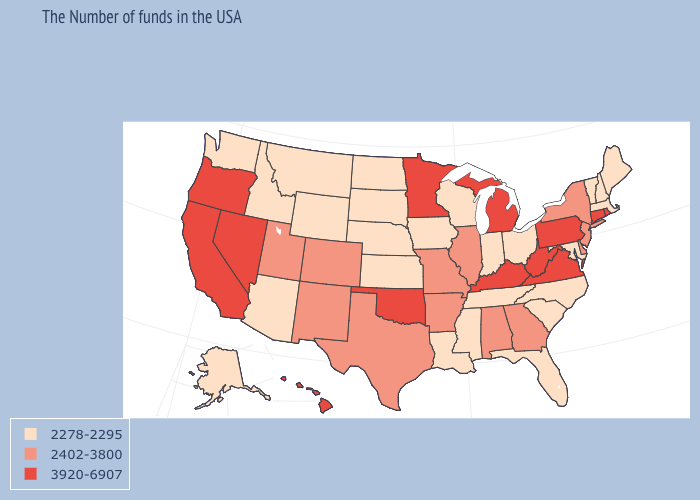Does the first symbol in the legend represent the smallest category?
Quick response, please. Yes. Does Wyoming have the lowest value in the USA?
Quick response, please. Yes. What is the lowest value in the USA?
Concise answer only. 2278-2295. Which states have the highest value in the USA?
Write a very short answer. Rhode Island, Connecticut, Pennsylvania, Virginia, West Virginia, Michigan, Kentucky, Minnesota, Oklahoma, Nevada, California, Oregon, Hawaii. Which states hav the highest value in the West?
Give a very brief answer. Nevada, California, Oregon, Hawaii. Which states hav the highest value in the MidWest?
Concise answer only. Michigan, Minnesota. Name the states that have a value in the range 2402-3800?
Write a very short answer. New York, New Jersey, Delaware, Georgia, Alabama, Illinois, Missouri, Arkansas, Texas, Colorado, New Mexico, Utah. Name the states that have a value in the range 2402-3800?
Concise answer only. New York, New Jersey, Delaware, Georgia, Alabama, Illinois, Missouri, Arkansas, Texas, Colorado, New Mexico, Utah. Does Oregon have the highest value in the USA?
Keep it brief. Yes. What is the highest value in states that border Georgia?
Quick response, please. 2402-3800. Name the states that have a value in the range 2278-2295?
Answer briefly. Maine, Massachusetts, New Hampshire, Vermont, Maryland, North Carolina, South Carolina, Ohio, Florida, Indiana, Tennessee, Wisconsin, Mississippi, Louisiana, Iowa, Kansas, Nebraska, South Dakota, North Dakota, Wyoming, Montana, Arizona, Idaho, Washington, Alaska. What is the highest value in the Northeast ?
Give a very brief answer. 3920-6907. Name the states that have a value in the range 2278-2295?
Short answer required. Maine, Massachusetts, New Hampshire, Vermont, Maryland, North Carolina, South Carolina, Ohio, Florida, Indiana, Tennessee, Wisconsin, Mississippi, Louisiana, Iowa, Kansas, Nebraska, South Dakota, North Dakota, Wyoming, Montana, Arizona, Idaho, Washington, Alaska. Name the states that have a value in the range 3920-6907?
Give a very brief answer. Rhode Island, Connecticut, Pennsylvania, Virginia, West Virginia, Michigan, Kentucky, Minnesota, Oklahoma, Nevada, California, Oregon, Hawaii. Which states hav the highest value in the Northeast?
Write a very short answer. Rhode Island, Connecticut, Pennsylvania. 